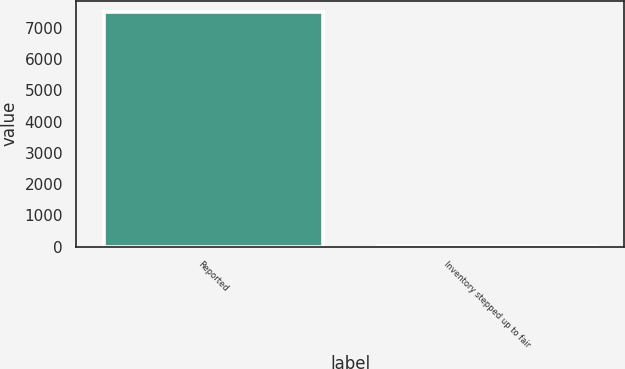Convert chart. <chart><loc_0><loc_0><loc_500><loc_500><bar_chart><fcel>Reported<fcel>Inventory stepped up to fair<nl><fcel>7495<fcel>36<nl></chart> 